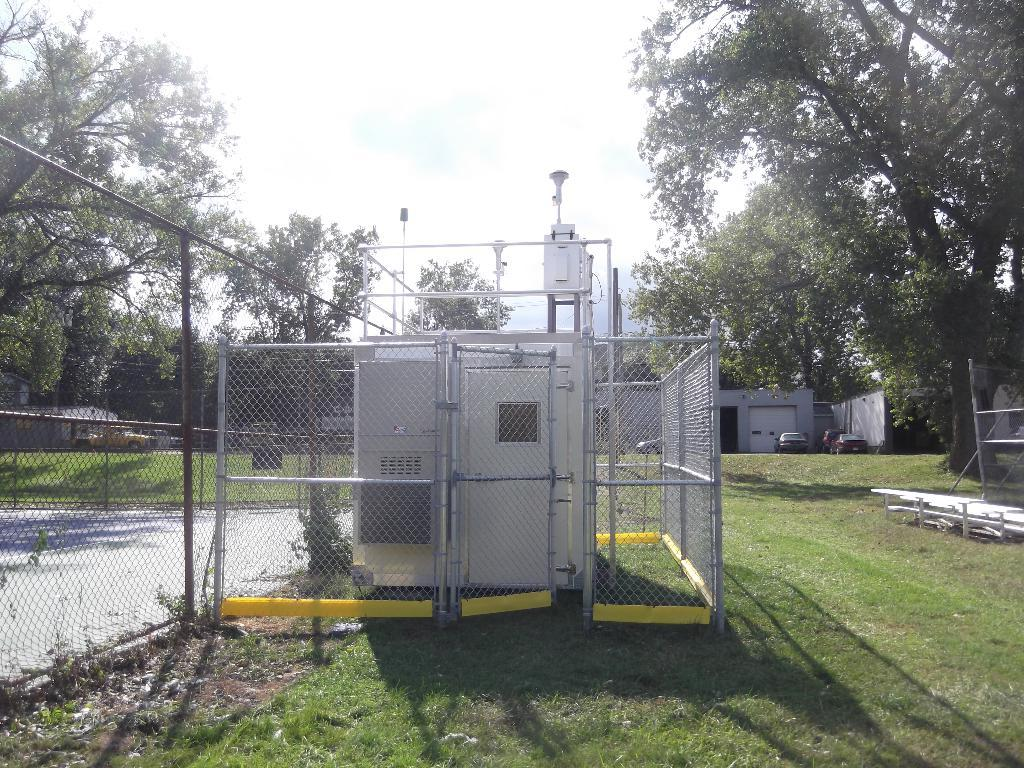What type of material is present in the image? There is mesh in the image. What structure can be seen in the image? There is a door in the image. What architectural element is visible in the image? There is a wall in the image. What barrier is featured in the image? There is a fence in the image. What type of vegetation is present in the image? There is grass in the image. What supports are visible in the image? There are poles in the image. What objects are present in the image? There are objects in the image. What structures can be seen in the background of the image? There are shelters in the background of the image. What type of vegetation is visible in the background of the image? There are trees in the background of the image. What type of transportation is visible in the background of the image? There are vehicles in the background of the image. What can be seen in the sky in the background of the image? There is sky visible in the background of the image. What language is being spoken by the market in the image? There is no market present in the image, and therefore no language being spoken. What is the sister's favorite color in the image? There is no sister present in the image, so we cannot determine her favorite color. 